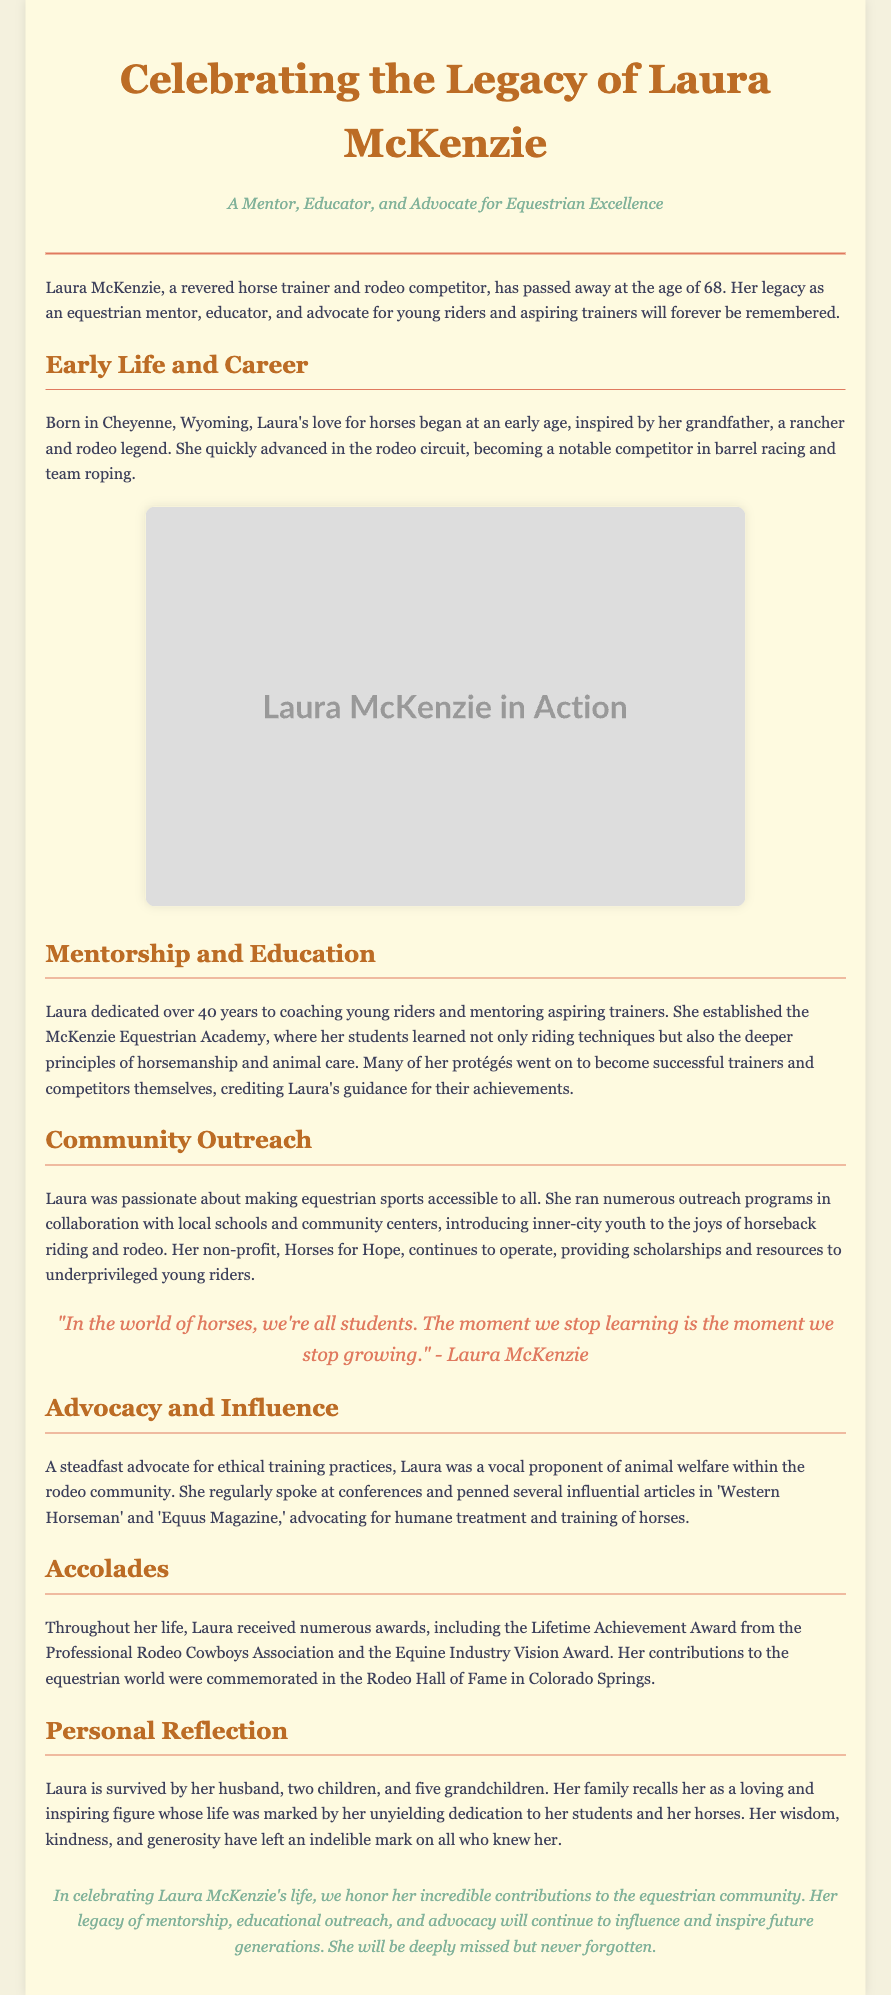What was Laura McKenzie's age at the time of her passing? The document states that Laura McKenzie passed away at the age of 68.
Answer: 68 Where was Laura McKenzie born? The document mentions that she was born in Cheyenne, Wyoming.
Answer: Cheyenne, Wyoming What was the name of the non-profit organization Laura established? The document states that Laura ran a non-profit called Horses for Hope.
Answer: Horses for Hope How many years did Laura dedicate to coaching young riders? The document indicates that Laura dedicated over 40 years to coaching young riders.
Answer: 40 years What award did Laura receive from the Professional Rodeo Cowboys Association? The document refers to the Lifetime Achievement Award from the Professional Rodeo Cowboys Association.
Answer: Lifetime Achievement Award Which equestrian disciplines was Laura noted for competing in? The document mentions her as a notable competitor in barrel racing and team roping.
Answer: Barrel racing and team roping What principle did Laura advocate for within the rodeo community? The document states she was a vocal proponent of animal welfare.
Answer: Animal welfare How many grandchildren did Laura have? The document indicates that Laura is survived by five grandchildren.
Answer: Five grandchildren What was the quote attributed to Laura McKenzie about learning? The document includes a quote that states, "In the world of horses, we're all students. The moment we stop learning is the moment we stop growing."
Answer: "In the world of horses, we're all students. The moment we stop learning is the moment we stop growing." 